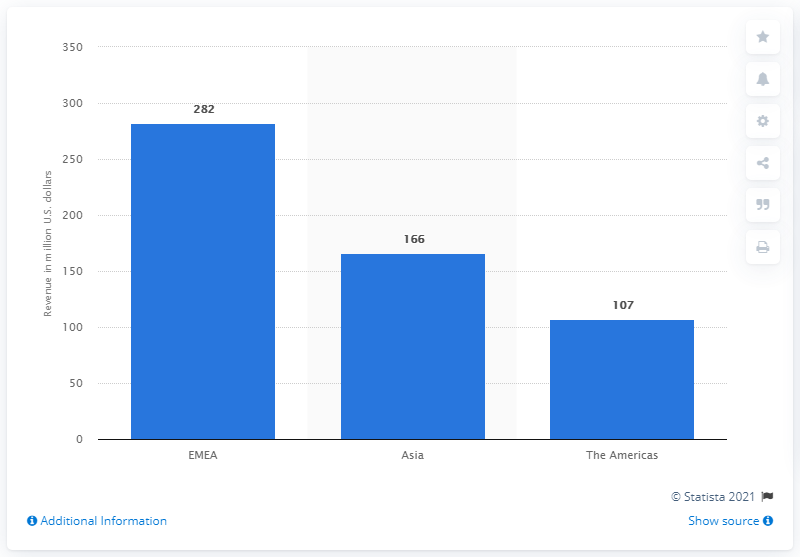Mention a couple of crucial points in this snapshot. Jimmy Choo's EMEA region's revenue in dollars for fiscal year 2020 was approximately 282 million dollars. 